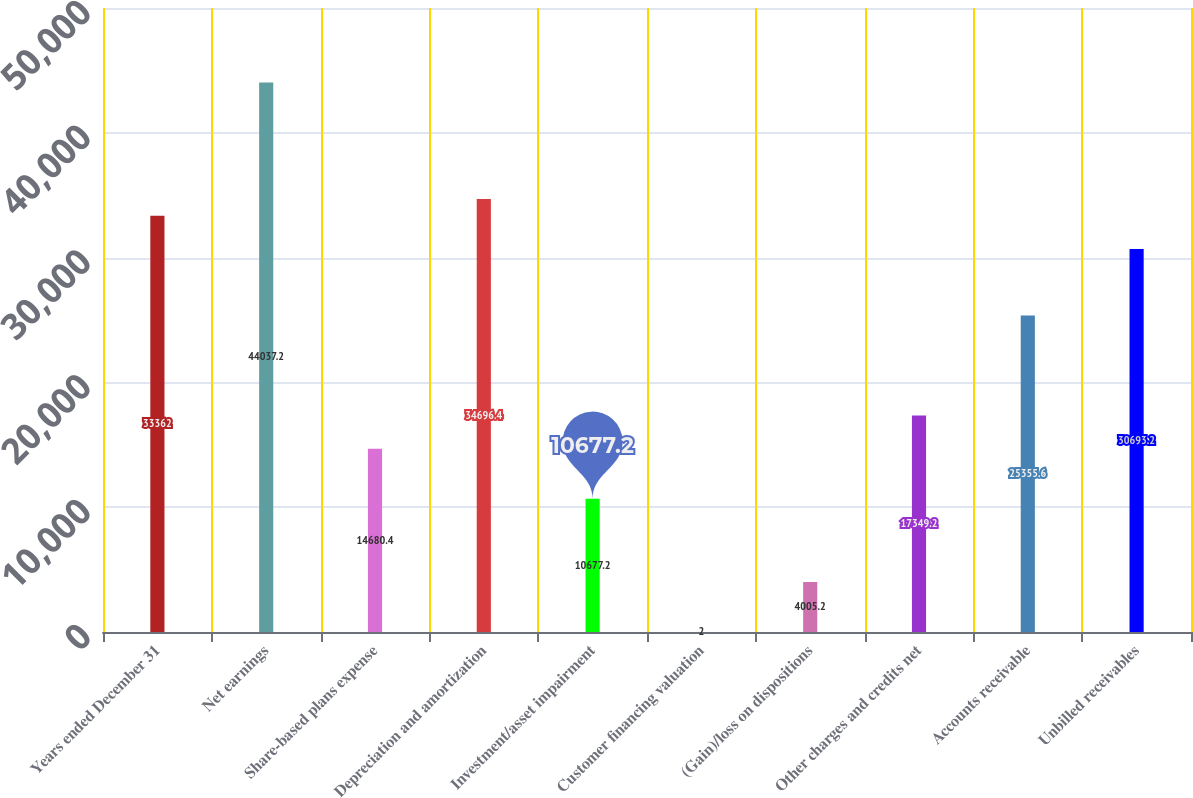Convert chart. <chart><loc_0><loc_0><loc_500><loc_500><bar_chart><fcel>Years ended December 31<fcel>Net earnings<fcel>Share-based plans expense<fcel>Depreciation and amortization<fcel>Investment/asset impairment<fcel>Customer financing valuation<fcel>(Gain)/loss on dispositions<fcel>Other charges and credits net<fcel>Accounts receivable<fcel>Unbilled receivables<nl><fcel>33362<fcel>44037.2<fcel>14680.4<fcel>34696.4<fcel>10677.2<fcel>2<fcel>4005.2<fcel>17349.2<fcel>25355.6<fcel>30693.2<nl></chart> 